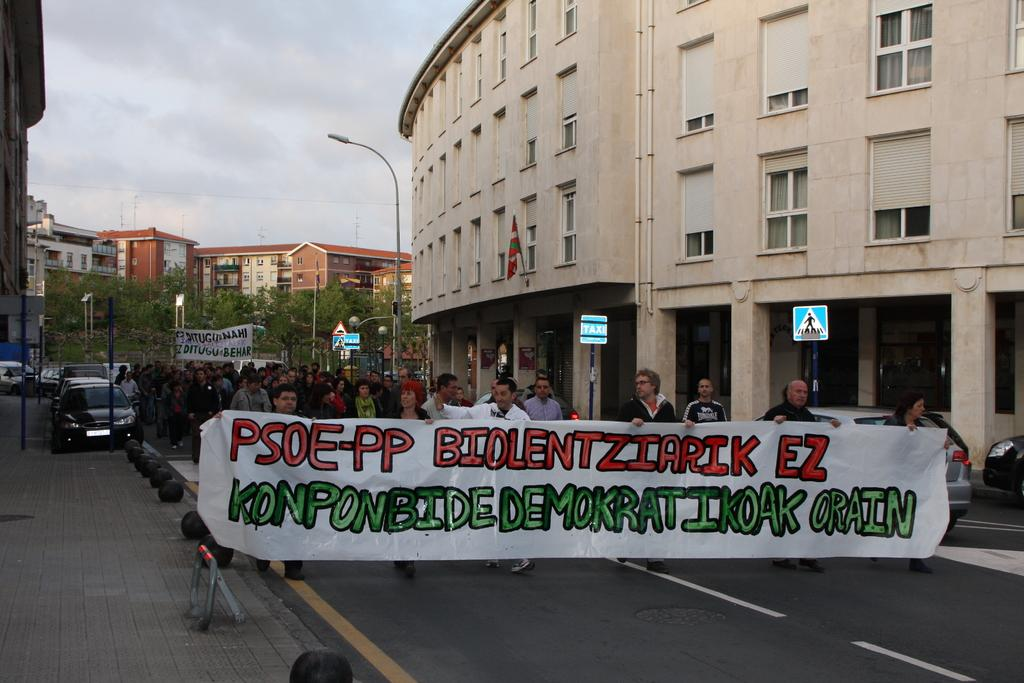What is happening in the image involving a group of people? There is a group of people in the image, and they are walking. What are the people carrying in the image? The group of people are carrying a banner. What can be seen in the background of the image? There are buildings and trees in the image. Can you tell me how many actors are visible in the image? There is no actor present in the image; it features a group of people walking and carrying a banner. Are there any flies buzzing around the people in the image? There is no mention of flies in the image, so it cannot be determined if any are present. 